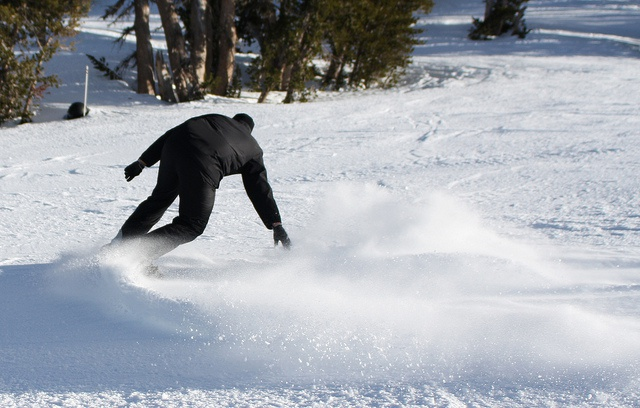Describe the objects in this image and their specific colors. I can see people in black, gray, lightgray, and darkgray tones and snowboard in black, darkgray, gray, and lightgray tones in this image. 